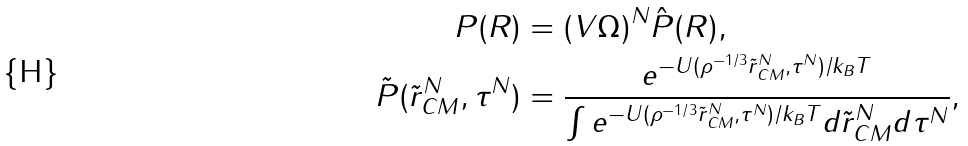Convert formula to latex. <formula><loc_0><loc_0><loc_500><loc_500>P ( R ) & = ( V \Omega ) ^ { N } \hat { P } ( R ) , \\ \tilde { P } ( \tilde { r } _ { C M } ^ { N } , \tau ^ { N } ) & = \frac { e ^ { - U ( \rho ^ { - 1 / 3 } \tilde { r } _ { C M } ^ { N } , \tau ^ { N } ) / k _ { B } T } } { \int e ^ { - U ( \rho ^ { - 1 / 3 } \tilde { r } _ { C M } ^ { N } , \tau ^ { N } ) / k _ { B } T } d \tilde { r } _ { C M } ^ { N } d \tau ^ { N } } ,</formula> 